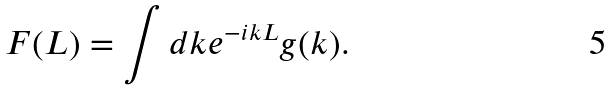Convert formula to latex. <formula><loc_0><loc_0><loc_500><loc_500>F ( L ) = \int d k e ^ { - i k L } g ( k ) .</formula> 